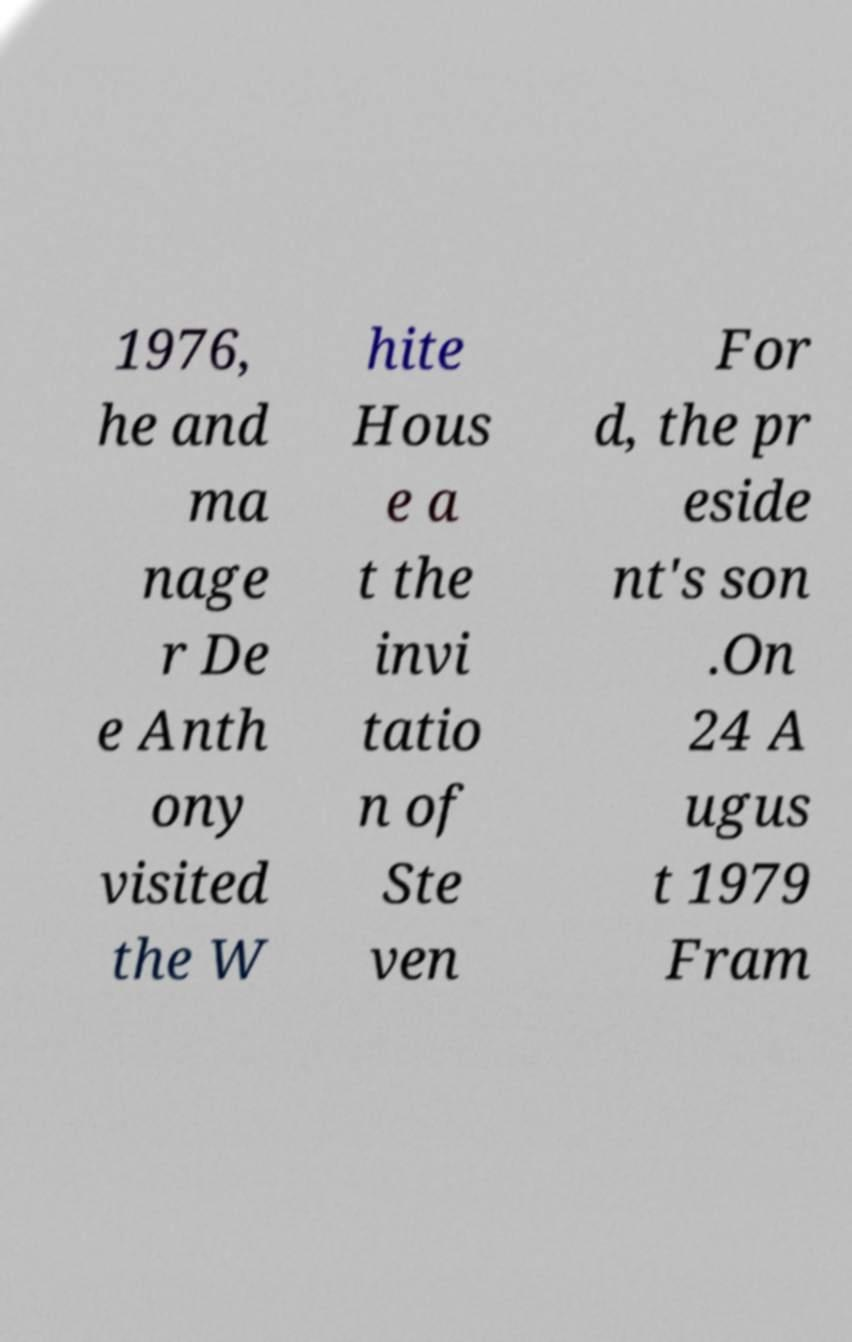There's text embedded in this image that I need extracted. Can you transcribe it verbatim? 1976, he and ma nage r De e Anth ony visited the W hite Hous e a t the invi tatio n of Ste ven For d, the pr eside nt's son .On 24 A ugus t 1979 Fram 